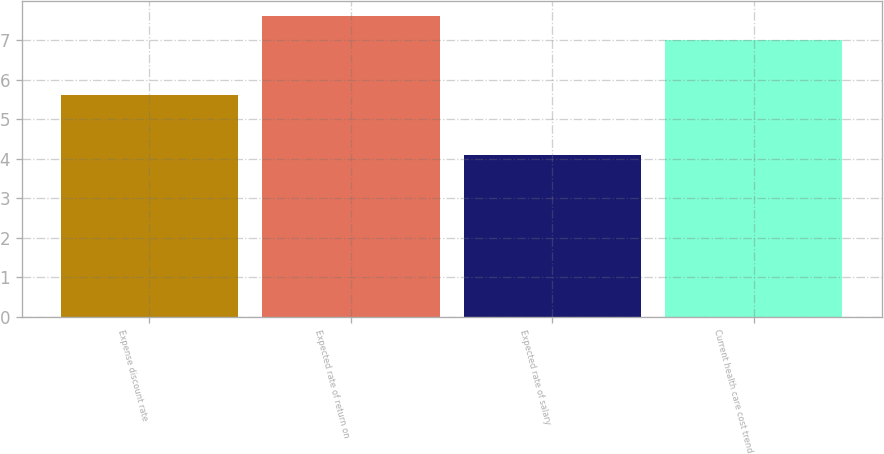Convert chart. <chart><loc_0><loc_0><loc_500><loc_500><bar_chart><fcel>Expense discount rate<fcel>Expected rate of return on<fcel>Expected rate of salary<fcel>Current health care cost trend<nl><fcel>5.6<fcel>7.6<fcel>4.1<fcel>7<nl></chart> 